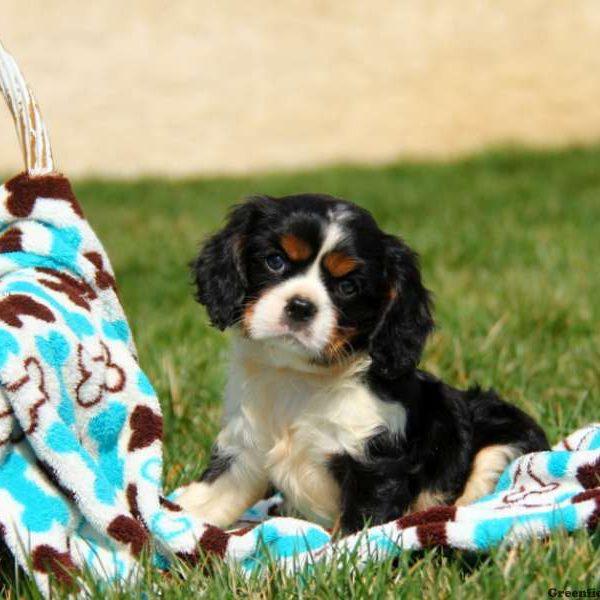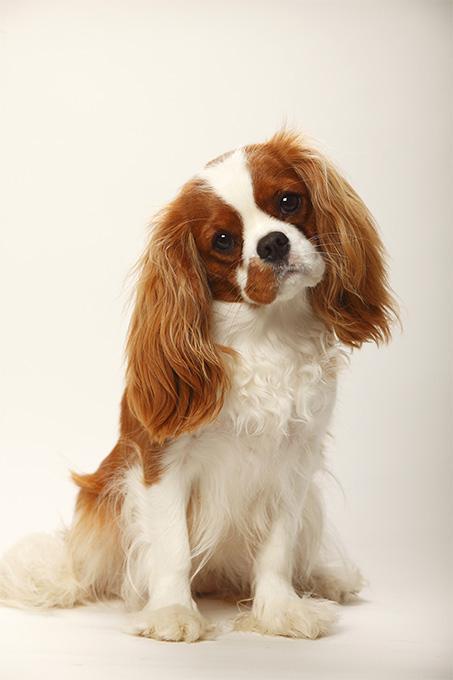The first image is the image on the left, the second image is the image on the right. Given the left and right images, does the statement "There is exactly one dog with black and white fur." hold true? Answer yes or no. Yes. The first image is the image on the left, the second image is the image on the right. For the images displayed, is the sentence "Pinkish flowers are in the background behind at least one dog that is sitting upright." factually correct? Answer yes or no. No. 